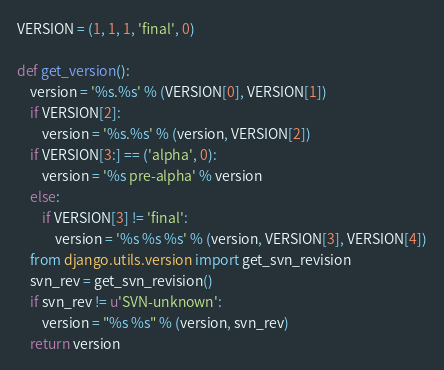<code> <loc_0><loc_0><loc_500><loc_500><_Python_>VERSION = (1, 1, 1, 'final', 0)

def get_version():
    version = '%s.%s' % (VERSION[0], VERSION[1])
    if VERSION[2]:
        version = '%s.%s' % (version, VERSION[2])
    if VERSION[3:] == ('alpha', 0):
        version = '%s pre-alpha' % version
    else:
        if VERSION[3] != 'final':
            version = '%s %s %s' % (version, VERSION[3], VERSION[4])
    from django.utils.version import get_svn_revision
    svn_rev = get_svn_revision()
    if svn_rev != u'SVN-unknown':
        version = "%s %s" % (version, svn_rev)
    return version
</code> 